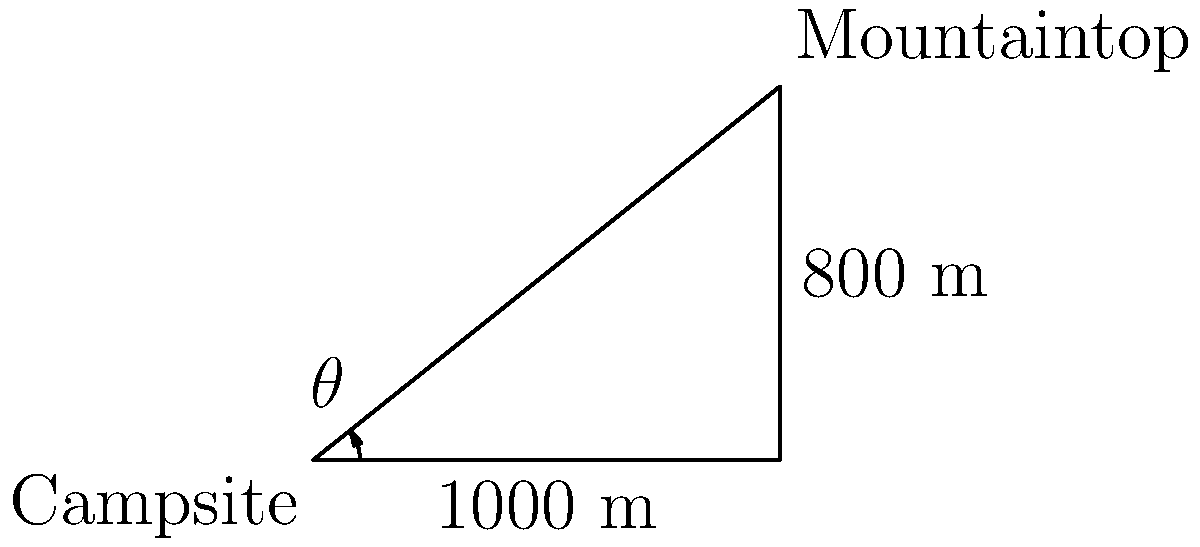While enjoying a camping trip in the mountains, you spot a beautiful peak from your campsite. Using your surveying equipment, you determine that the horizontal distance to the peak is 1000 meters, and its vertical height above your campsite is 800 meters. What is the angle of elevation (θ) from your campsite to the mountaintop? To solve this problem, we can use trigonometry, specifically the tangent function. Let's approach this step-by-step:

1) We have a right triangle where:
   - The adjacent side (horizontal distance) is 1000 meters
   - The opposite side (vertical height) is 800 meters
   - We need to find the angle θ

2) The tangent of an angle in a right triangle is defined as the ratio of the opposite side to the adjacent side:

   $$\tan(\theta) = \frac{\text{opposite}}{\text{adjacent}}$$

3) Plugging in our values:

   $$\tan(\theta) = \frac{800}{1000} = 0.8$$

4) To find θ, we need to use the inverse tangent (arctangent) function:

   $$\theta = \tan^{-1}(0.8)$$

5) Using a calculator or trigonometric tables:

   $$\theta \approx 38.66^\circ$$

6) Rounding to the nearest degree:

   $$\theta \approx 39^\circ$$

Therefore, the angle of elevation from your campsite to the mountaintop is approximately 39°.
Answer: 39° 